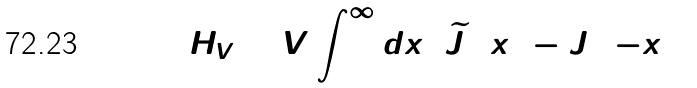<formula> <loc_0><loc_0><loc_500><loc_500>H _ { V } = V \int _ { 0 } ^ { \infty } d x \, ( \widetilde { J } _ { 3 } ( x ) - J _ { 3 } ( - x ) )</formula> 